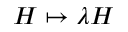Convert formula to latex. <formula><loc_0><loc_0><loc_500><loc_500>H \mapsto \lambda H</formula> 